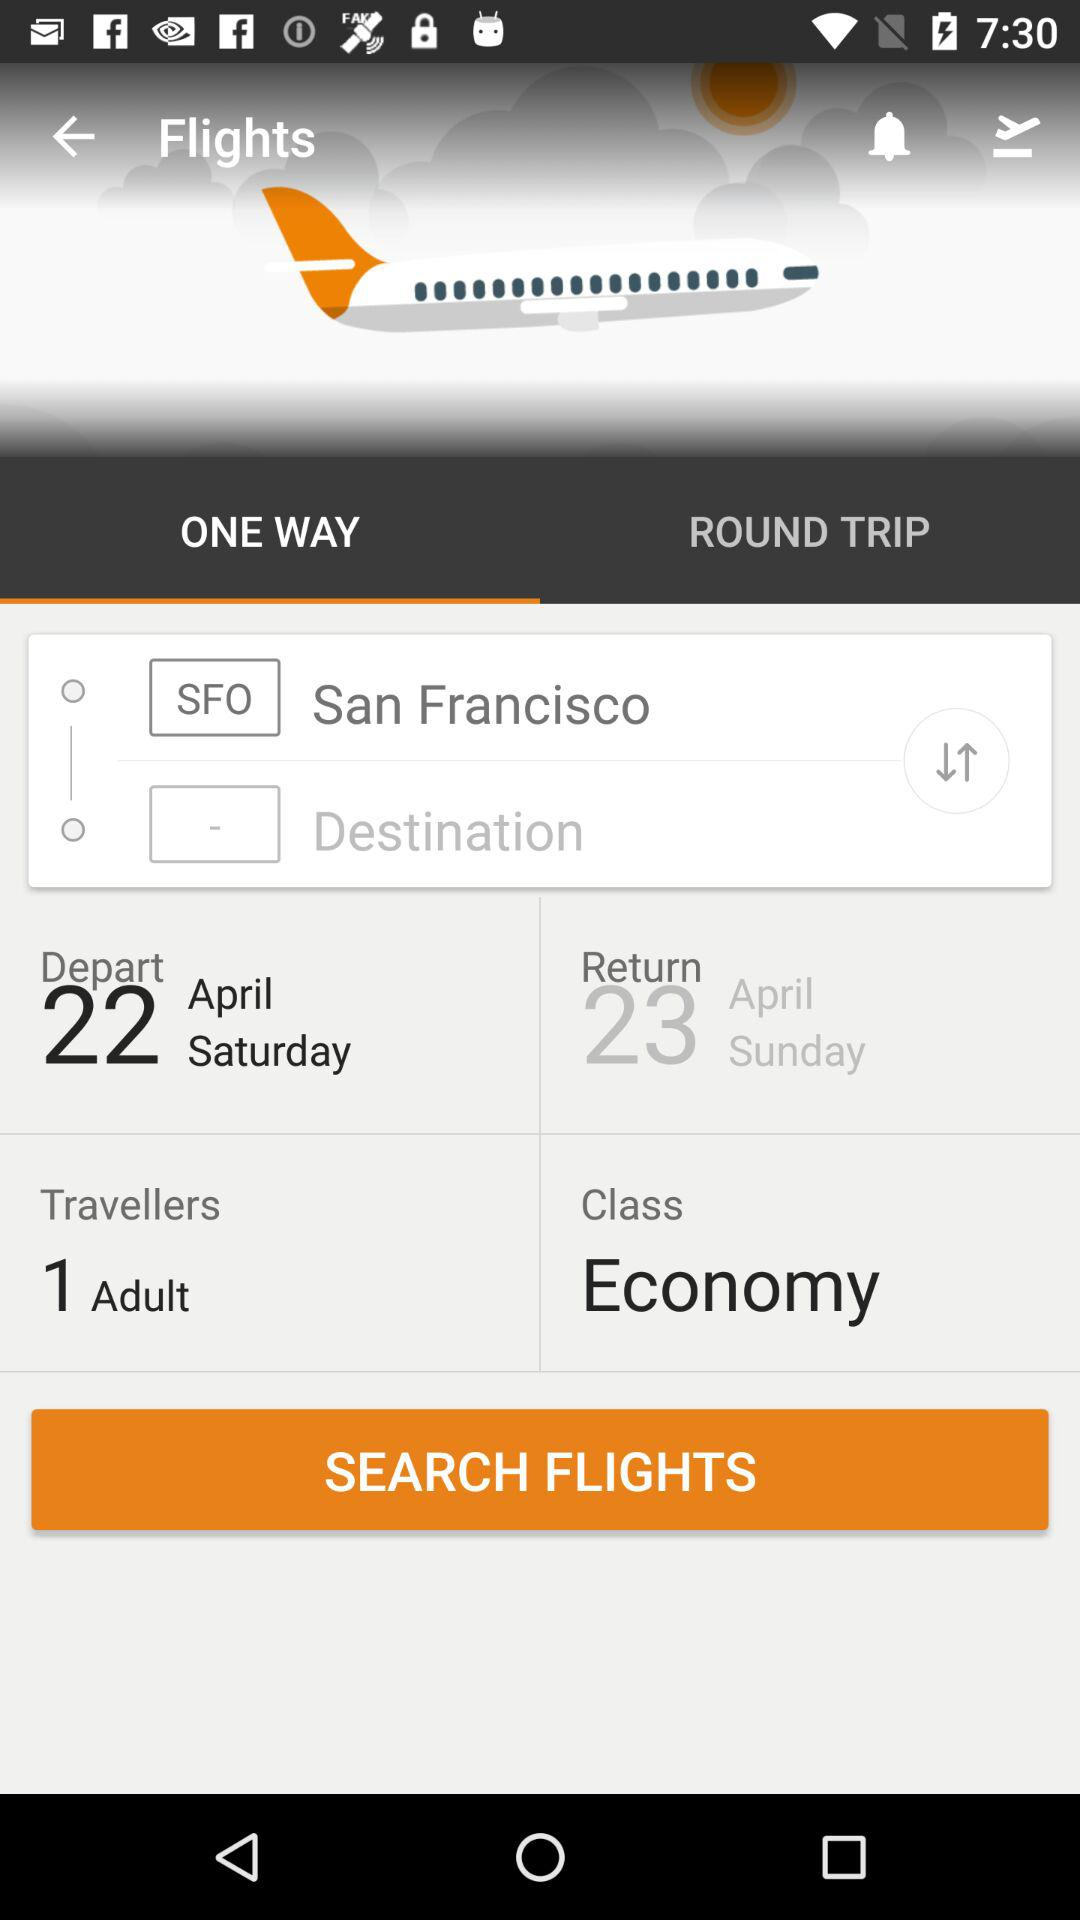For how many travelers is the flight booking process in progress? The flight booking process is in progress for 1 traveler. 